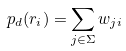<formula> <loc_0><loc_0><loc_500><loc_500>p _ { d } ( { r } _ { i } ) = \sum _ { j \in \Sigma } w _ { j i }</formula> 